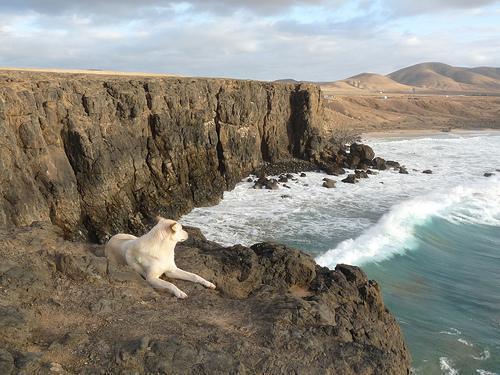How many dogs?
Give a very brief answer. 1. 